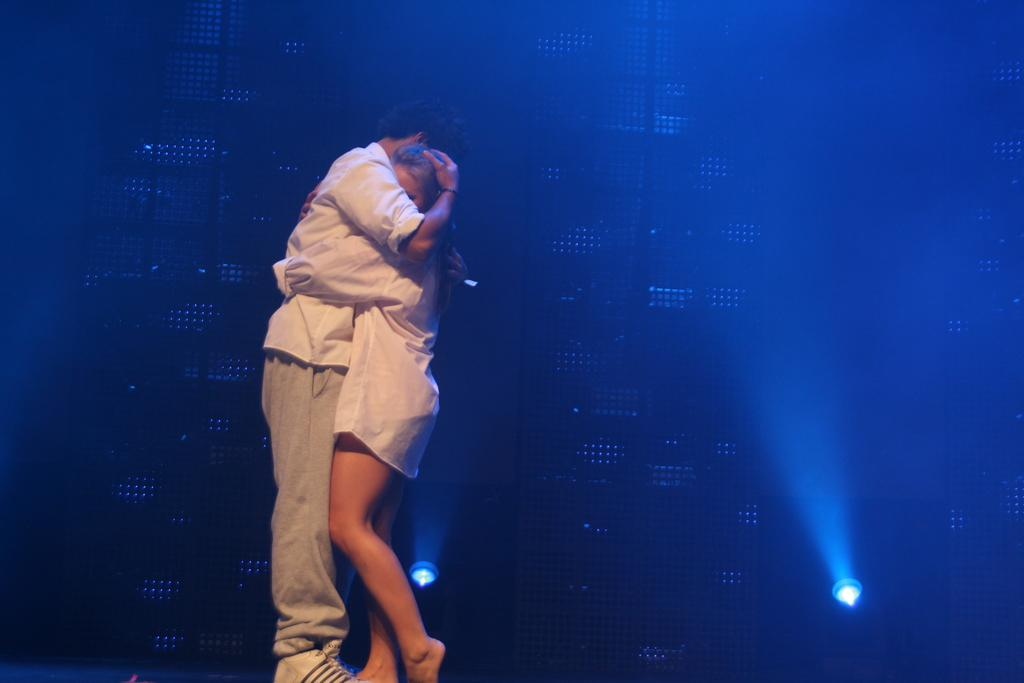What is happening between the person and the woman in the image? The person and the woman are hugging each other in the image. What position are they in while hugging? They are standing while hugging each other. What are they wearing in the image? They are both wearing white shirts. What can be seen on the floor behind them? There are two lights on the floor behind them. What type of creature is standing next to the woman in the image? There is no creature present in the image; it only features a person and a woman hugging each other. What type of polish is being applied to the person's nails in the image? There is no indication of nail polish or any beauty treatment in the image; it only shows a person and a woman hugging each other. 